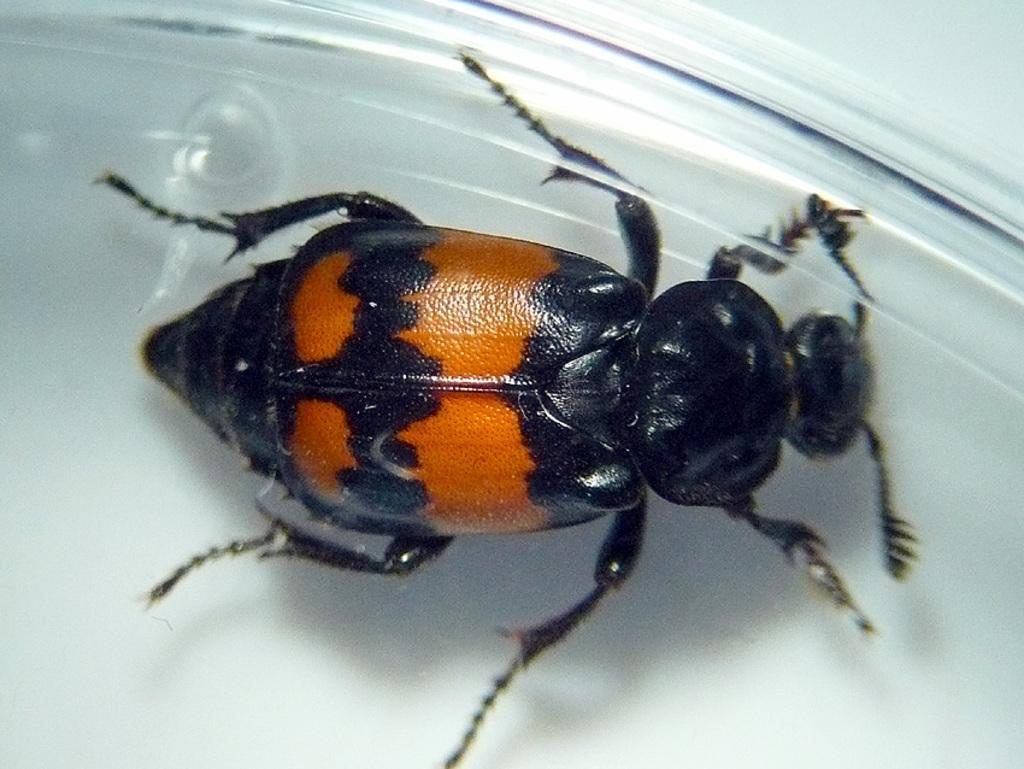Please provide a concise description of this image. In this image we can see an insect. In the background of the image there is a white surface. 